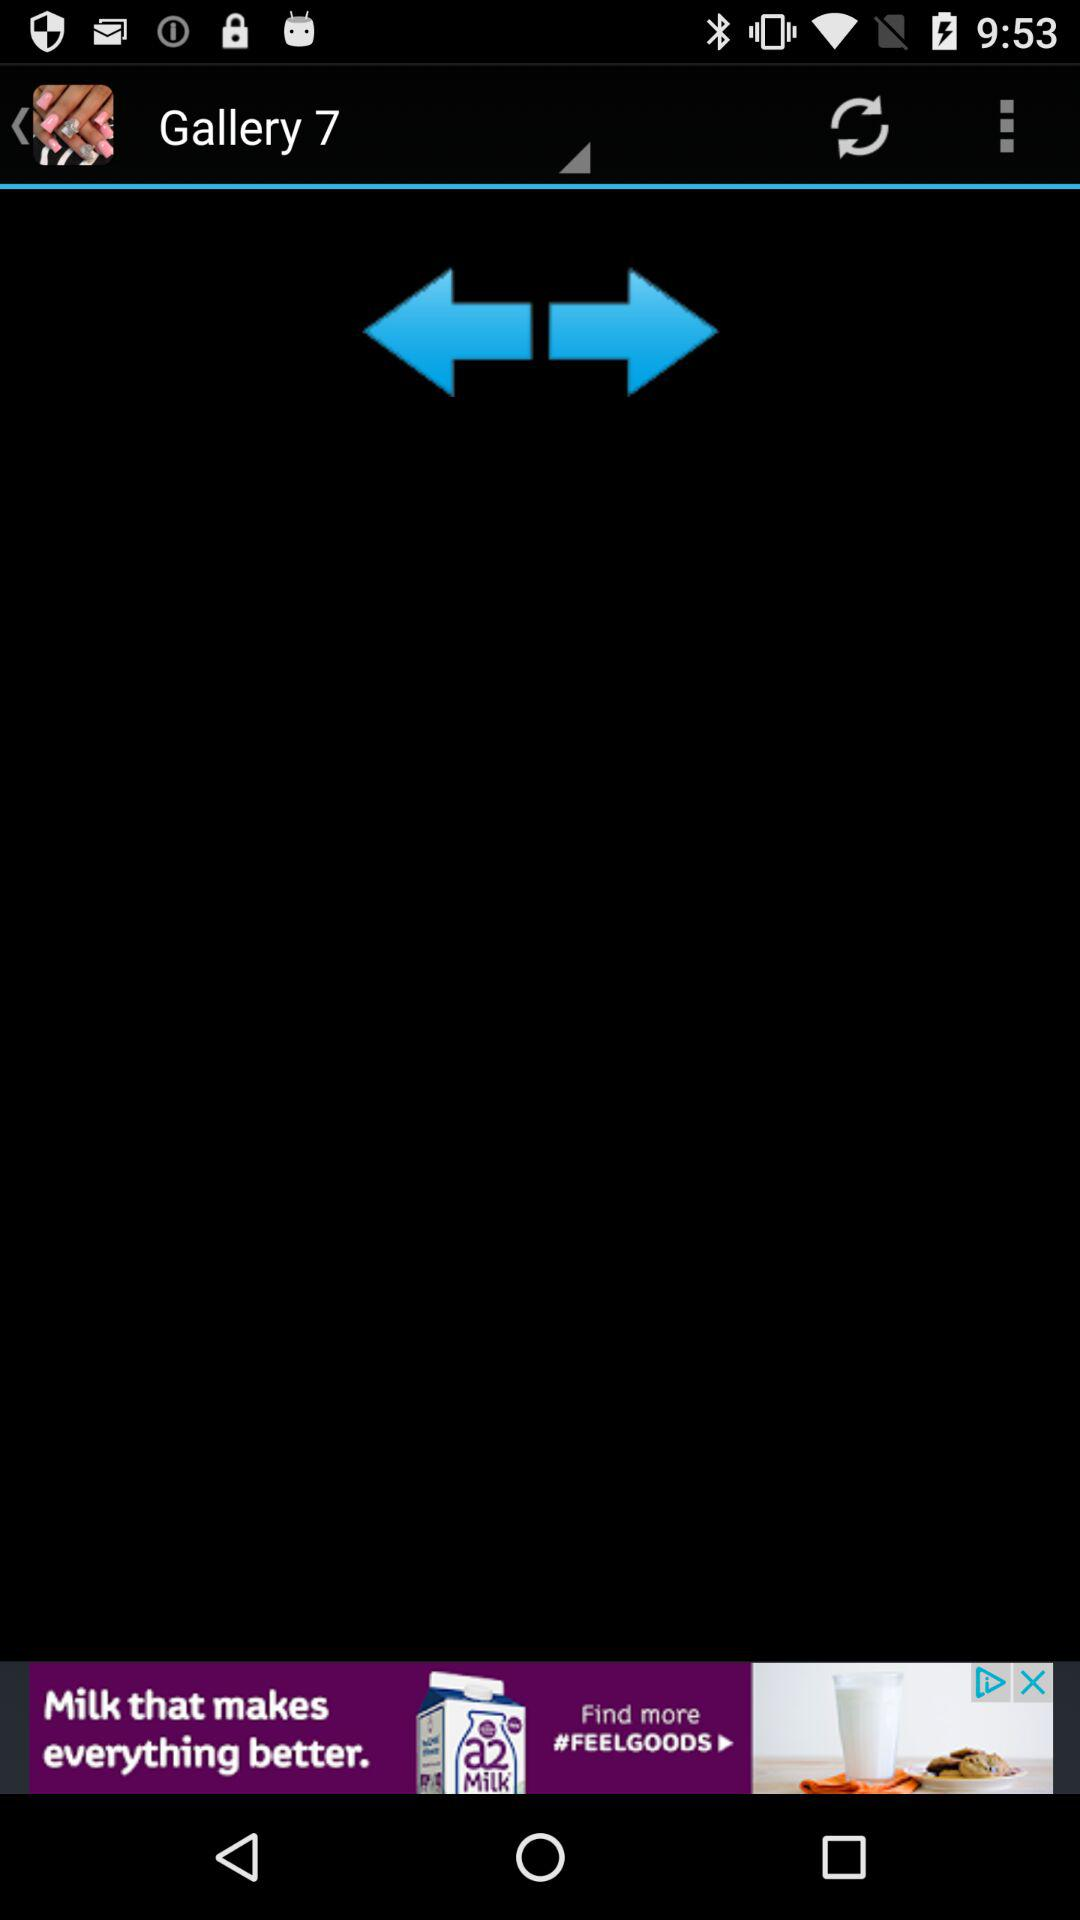What is the number of gallery?
When the provided information is insufficient, respond with <no answer>. <no answer> 